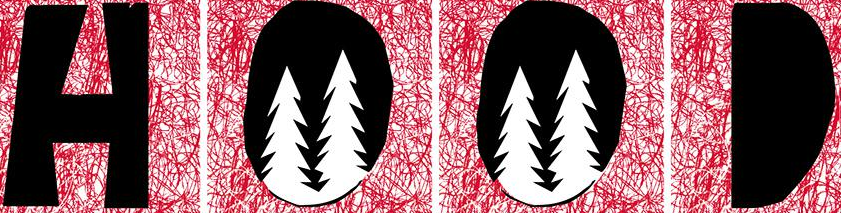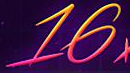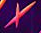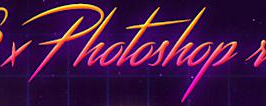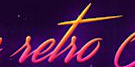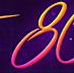Read the text from these images in sequence, separated by a semicolon. HOOD; 16; ×; Photoshop; setso; 8 